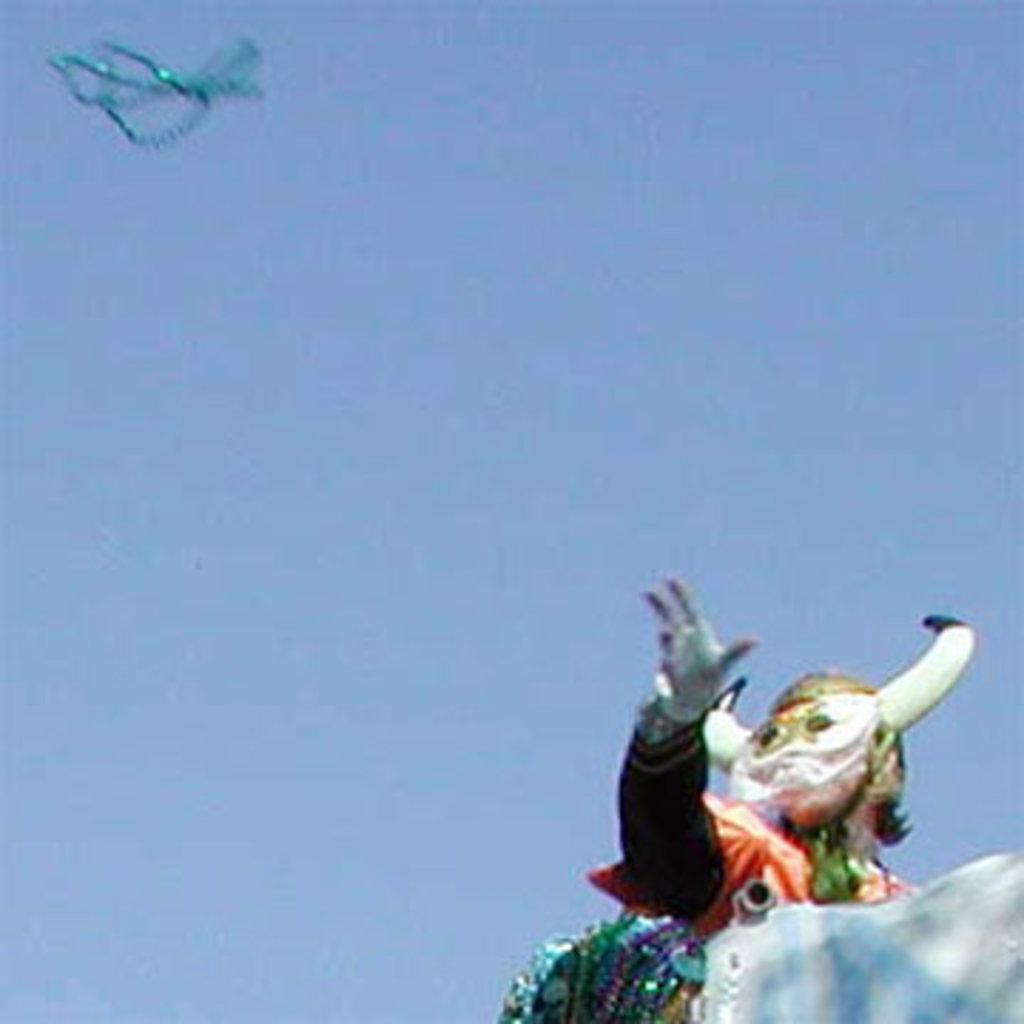What is the person in the image wearing? The person in the image is wearing a costume. What can be seen in the background of the image? The background of the image includes the sky. Can you describe the object in the left top corner of the image? Unfortunately, the facts provided do not give any information about the object in the left top corner of the image. What type of bag is the person carrying in the image? There is no bag visible in the image. What color is the shirt the person is wearing under the costume? The facts provided do not give any information about the person's shirt, as they only mention the costume. 